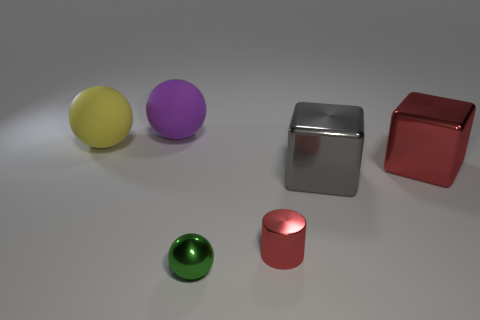Are there any green things that have the same size as the green ball?
Your answer should be very brief. No. How many things are left of the cylinder and to the right of the large yellow object?
Ensure brevity in your answer.  2. There is a yellow sphere; how many gray cubes are in front of it?
Make the answer very short. 1. Are there any other large objects of the same shape as the gray thing?
Keep it short and to the point. Yes. There is a gray metallic thing; is it the same shape as the red metallic thing on the left side of the big gray thing?
Give a very brief answer. No. How many spheres are red metal objects or large rubber objects?
Your response must be concise. 2. There is a tiny metallic object behind the green shiny object; what shape is it?
Your answer should be compact. Cylinder. What number of big brown balls have the same material as the big gray cube?
Ensure brevity in your answer.  0. Are there fewer small shiny spheres that are on the right side of the tiny red metal cylinder than large blue metal objects?
Offer a very short reply. No. There is a shiny thing in front of the small thing that is on the right side of the green object; what size is it?
Offer a very short reply. Small. 